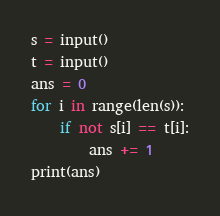<code> <loc_0><loc_0><loc_500><loc_500><_Python_>s = input()
t = input()
ans = 0
for i in range(len(s)):
    if not s[i] == t[i]:
        ans += 1
print(ans)</code> 